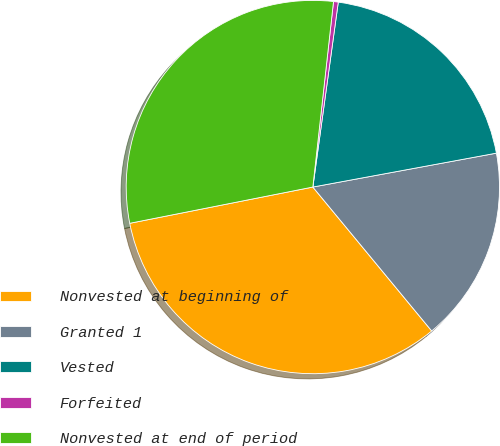<chart> <loc_0><loc_0><loc_500><loc_500><pie_chart><fcel>Nonvested at beginning of<fcel>Granted 1<fcel>Vested<fcel>Forfeited<fcel>Nonvested at end of period<nl><fcel>32.88%<fcel>16.92%<fcel>19.92%<fcel>0.41%<fcel>29.88%<nl></chart> 